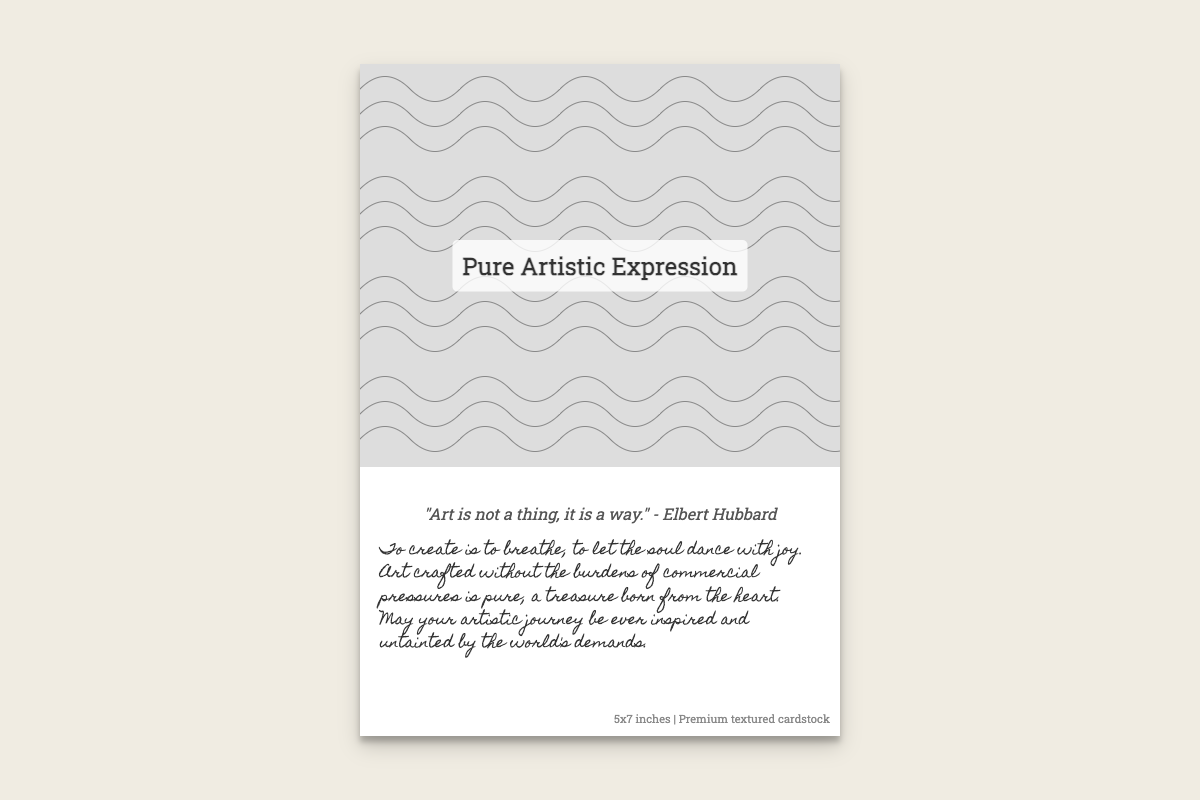What is the title of the card? The title is prominently displayed in the card cover section, which reads "Pure Artistic Expression."
Answer: Pure Artistic Expression Who is the author of the quote on the card? The quote is attributed to Elbert Hubbard as stated right below the quote itself.
Answer: Elbert Hubbard What is the size of the card? The dimensions of the card are mentioned in the additional details section as 5x7 inches.
Answer: 5x7 inches What type of cardstock is used for the card? The additional details specify that the card is made from premium textured cardstock.
Answer: Premium textured cardstock What is the main theme of the quote? The quote emphasizes the essence and approach to art rather than a physical representation, encapsulating a deeper meaning about artistic expression.
Answer: A way What is the color of the quote text? The quote is styled in a specific color, which is mentioned in the CSS style section of the document.
Answer: #555 What style is the handwritten text written in? The handwritten text utilizes a specific font family, which is mentioned in the CSS, giving it a unique cursive appearance.
Answer: Homemade Apple What visual elements are used in the card? The card features an intricate pen and ink drawing design that represents abstract shapes and forms.
Answer: Abstract shapes and forms 